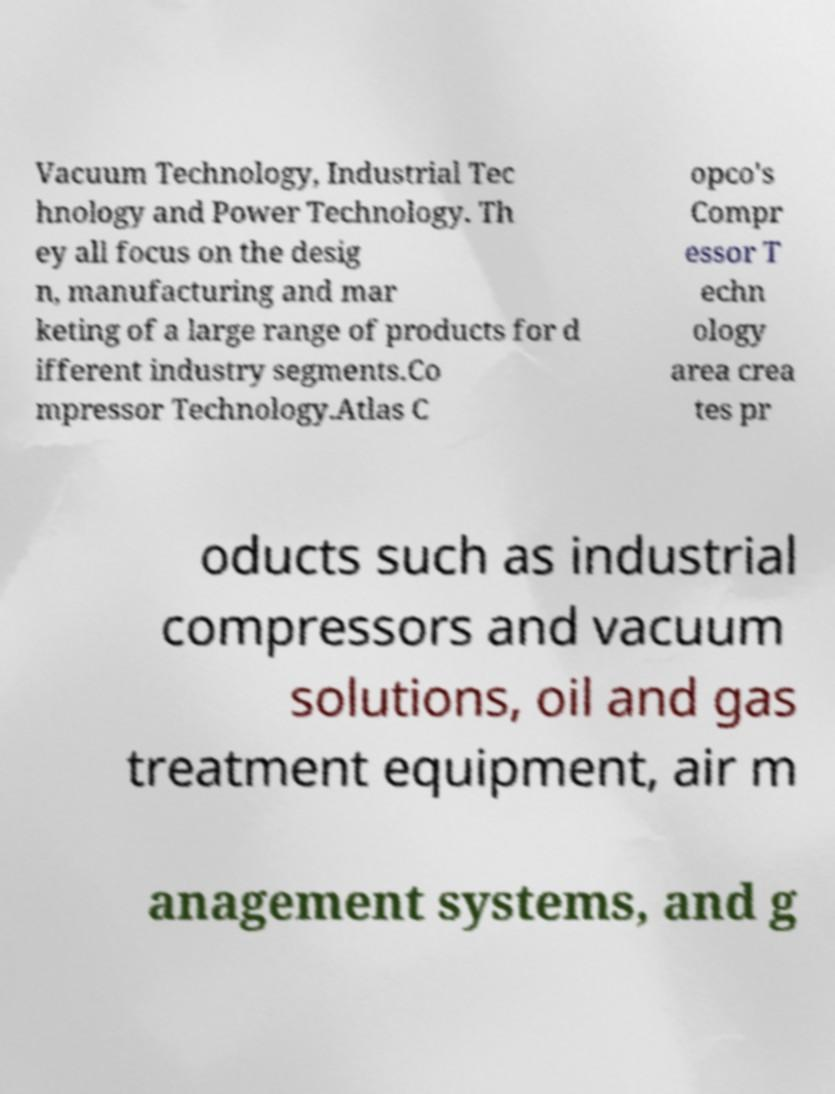There's text embedded in this image that I need extracted. Can you transcribe it verbatim? Vacuum Technology, Industrial Tec hnology and Power Technology. Th ey all focus on the desig n, manufacturing and mar keting of a large range of products for d ifferent industry segments.Co mpressor Technology.Atlas C opco's Compr essor T echn ology area crea tes pr oducts such as industrial compressors and vacuum solutions, oil and gas treatment equipment, air m anagement systems, and g 